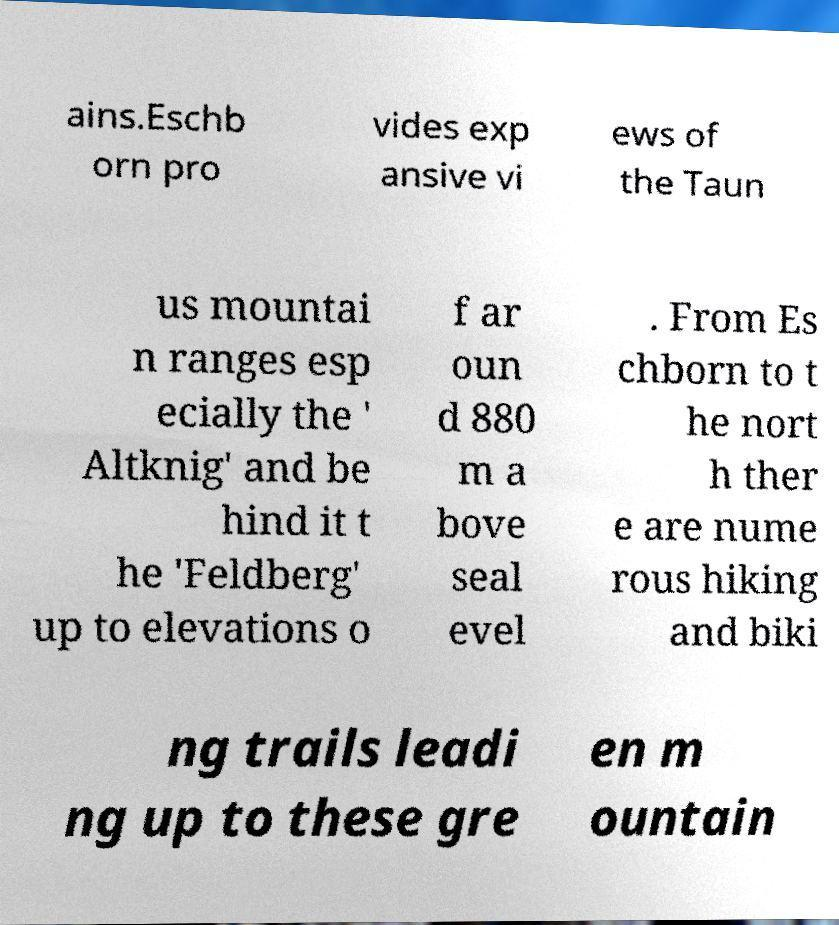For documentation purposes, I need the text within this image transcribed. Could you provide that? ains.Eschb orn pro vides exp ansive vi ews of the Taun us mountai n ranges esp ecially the ' Altknig' and be hind it t he 'Feldberg' up to elevations o f ar oun d 880 m a bove seal evel . From Es chborn to t he nort h ther e are nume rous hiking and biki ng trails leadi ng up to these gre en m ountain 